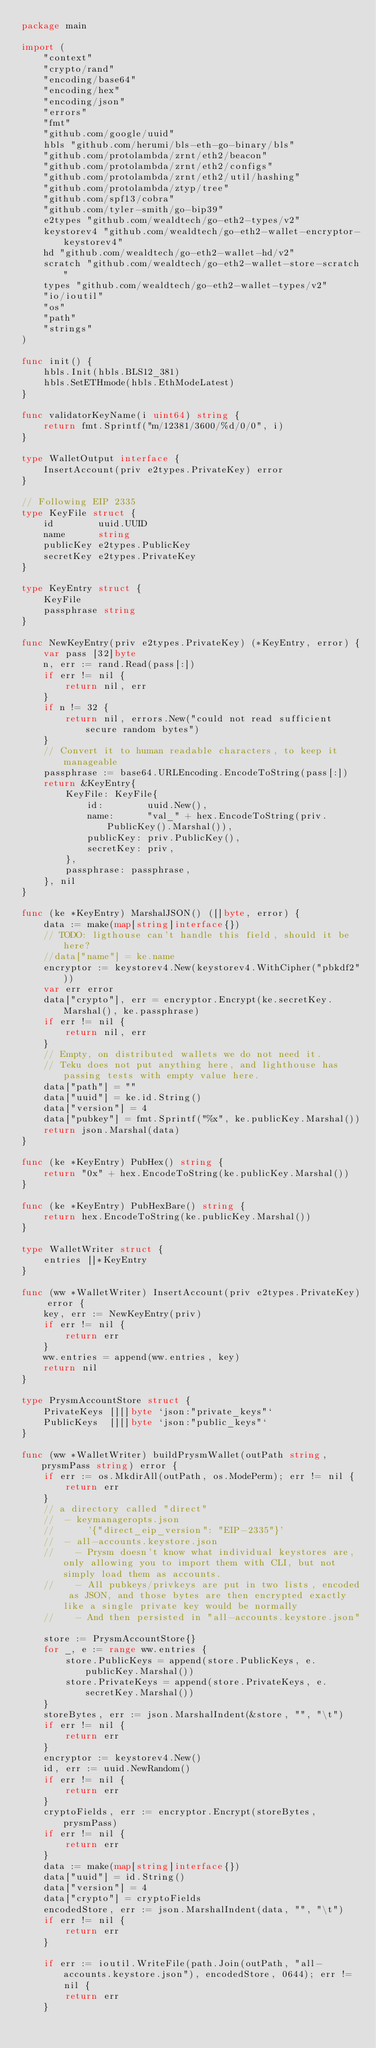<code> <loc_0><loc_0><loc_500><loc_500><_Go_>package main

import (
	"context"
	"crypto/rand"
	"encoding/base64"
	"encoding/hex"
	"encoding/json"
	"errors"
	"fmt"
	"github.com/google/uuid"
	hbls "github.com/herumi/bls-eth-go-binary/bls"
	"github.com/protolambda/zrnt/eth2/beacon"
	"github.com/protolambda/zrnt/eth2/configs"
	"github.com/protolambda/zrnt/eth2/util/hashing"
	"github.com/protolambda/ztyp/tree"
	"github.com/spf13/cobra"
	"github.com/tyler-smith/go-bip39"
	e2types "github.com/wealdtech/go-eth2-types/v2"
	keystorev4 "github.com/wealdtech/go-eth2-wallet-encryptor-keystorev4"
	hd "github.com/wealdtech/go-eth2-wallet-hd/v2"
	scratch "github.com/wealdtech/go-eth2-wallet-store-scratch"
	types "github.com/wealdtech/go-eth2-wallet-types/v2"
	"io/ioutil"
	"os"
	"path"
	"strings"
)

func init() {
	hbls.Init(hbls.BLS12_381)
	hbls.SetETHmode(hbls.EthModeLatest)
}

func validatorKeyName(i uint64) string {
	return fmt.Sprintf("m/12381/3600/%d/0/0", i)
}

type WalletOutput interface {
	InsertAccount(priv e2types.PrivateKey) error
}

// Following EIP 2335
type KeyFile struct {
	id        uuid.UUID
	name      string
	publicKey e2types.PublicKey
	secretKey e2types.PrivateKey
}

type KeyEntry struct {
	KeyFile
	passphrase string
}

func NewKeyEntry(priv e2types.PrivateKey) (*KeyEntry, error) {
	var pass [32]byte
	n, err := rand.Read(pass[:])
	if err != nil {
		return nil, err
	}
	if n != 32 {
		return nil, errors.New("could not read sufficient secure random bytes")
	}
	// Convert it to human readable characters, to keep it manageable
	passphrase := base64.URLEncoding.EncodeToString(pass[:])
	return &KeyEntry{
		KeyFile: KeyFile{
			id:        uuid.New(),
			name:      "val_" + hex.EncodeToString(priv.PublicKey().Marshal()),
			publicKey: priv.PublicKey(),
			secretKey: priv,
		},
		passphrase: passphrase,
	}, nil
}

func (ke *KeyEntry) MarshalJSON() ([]byte, error) {
	data := make(map[string]interface{})
	// TODO: ligthouse can't handle this field, should it be here?
	//data["name"] = ke.name
	encryptor := keystorev4.New(keystorev4.WithCipher("pbkdf2"))
	var err error
	data["crypto"], err = encryptor.Encrypt(ke.secretKey.Marshal(), ke.passphrase)
	if err != nil {
		return nil, err
	}
	// Empty, on distributed wallets we do not need it.
	// Teku does not put anything here, and lighthouse has passing tests with empty value here.
	data["path"] = ""
	data["uuid"] = ke.id.String()
	data["version"] = 4
	data["pubkey"] = fmt.Sprintf("%x", ke.publicKey.Marshal())
	return json.Marshal(data)
}

func (ke *KeyEntry) PubHex() string {
	return "0x" + hex.EncodeToString(ke.publicKey.Marshal())
}

func (ke *KeyEntry) PubHexBare() string {
	return hex.EncodeToString(ke.publicKey.Marshal())
}

type WalletWriter struct {
	entries []*KeyEntry
}

func (ww *WalletWriter) InsertAccount(priv e2types.PrivateKey) error {
	key, err := NewKeyEntry(priv)
	if err != nil {
		return err
	}
	ww.entries = append(ww.entries, key)
	return nil
}

type PrysmAccountStore struct {
	PrivateKeys [][]byte `json:"private_keys"`
	PublicKeys  [][]byte `json:"public_keys"`
}

func (ww *WalletWriter) buildPrysmWallet(outPath string, prysmPass string) error {
	if err := os.MkdirAll(outPath, os.ModePerm); err != nil {
		return err
	}
	// a directory called "direct"
	//  - keymanageropts.json
	//      '{"direct_eip_version": "EIP-2335"}'
	//  - all-accounts.keystore.json
	//    - Prysm doesn't know what individual keystores are, only allowing you to import them with CLI, but not simply load them as accounts.
	//    - All pubkeys/privkeys are put in two lists, encoded as JSON, and those bytes are then encrypted exactly like a single private key would be normally
	//    - And then persisted in "all-accounts.keystore.json"

	store := PrysmAccountStore{}
	for _, e := range ww.entries {
		store.PublicKeys = append(store.PublicKeys, e.publicKey.Marshal())
		store.PrivateKeys = append(store.PrivateKeys, e.secretKey.Marshal())
	}
	storeBytes, err := json.MarshalIndent(&store, "", "\t")
	if err != nil {
		return err
	}
	encryptor := keystorev4.New()
	id, err := uuid.NewRandom()
	if err != nil {
		return err
	}
	cryptoFields, err := encryptor.Encrypt(storeBytes, prysmPass)
	if err != nil {
		return err
	}
	data := make(map[string]interface{})
	data["uuid"] = id.String()
	data["version"] = 4
	data["crypto"] = cryptoFields
	encodedStore, err := json.MarshalIndent(data, "", "\t")
	if err != nil {
		return err
	}

	if err := ioutil.WriteFile(path.Join(outPath, "all-accounts.keystore.json"), encodedStore, 0644); err != nil {
		return err
	}</code> 